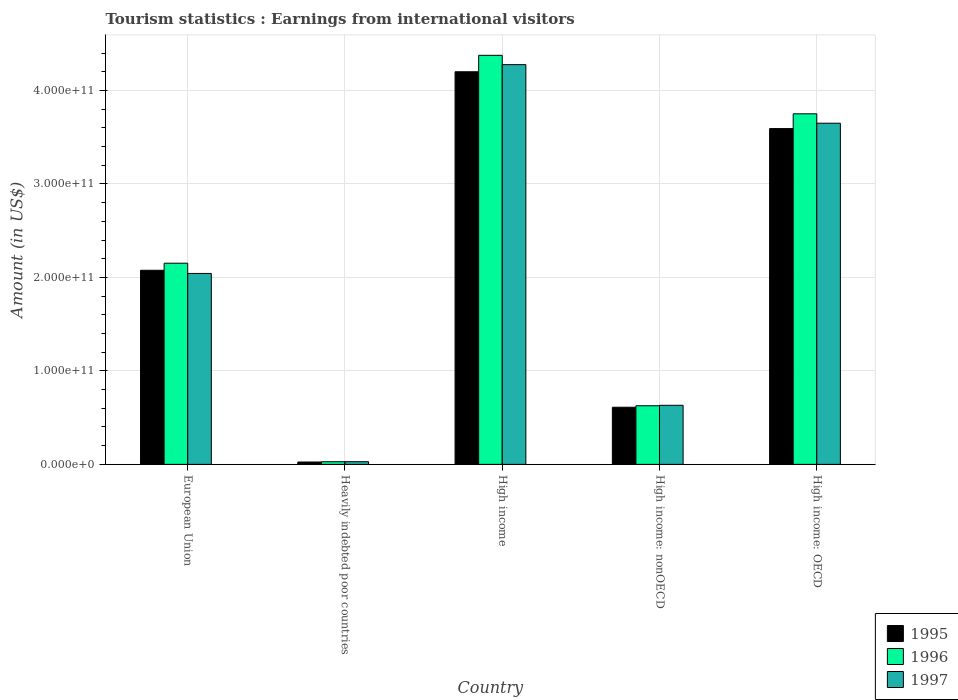How many groups of bars are there?
Your answer should be very brief. 5. How many bars are there on the 4th tick from the right?
Your answer should be compact. 3. In how many cases, is the number of bars for a given country not equal to the number of legend labels?
Ensure brevity in your answer.  0. What is the earnings from international visitors in 1997 in Heavily indebted poor countries?
Give a very brief answer. 2.86e+09. Across all countries, what is the maximum earnings from international visitors in 1997?
Keep it short and to the point. 4.28e+11. Across all countries, what is the minimum earnings from international visitors in 1995?
Offer a very short reply. 2.53e+09. In which country was the earnings from international visitors in 1995 maximum?
Your answer should be very brief. High income. In which country was the earnings from international visitors in 1997 minimum?
Your answer should be very brief. Heavily indebted poor countries. What is the total earnings from international visitors in 1995 in the graph?
Provide a short and direct response. 1.05e+12. What is the difference between the earnings from international visitors in 1997 in European Union and that in High income?
Your response must be concise. -2.23e+11. What is the difference between the earnings from international visitors in 1997 in European Union and the earnings from international visitors in 1995 in High income: nonOECD?
Your response must be concise. 1.43e+11. What is the average earnings from international visitors in 1995 per country?
Offer a terse response. 2.10e+11. What is the difference between the earnings from international visitors of/in 1996 and earnings from international visitors of/in 1995 in High income: OECD?
Your answer should be compact. 1.58e+1. In how many countries, is the earnings from international visitors in 1996 greater than 40000000000 US$?
Keep it short and to the point. 4. What is the ratio of the earnings from international visitors in 1996 in European Union to that in High income?
Keep it short and to the point. 0.49. Is the earnings from international visitors in 1996 in European Union less than that in High income?
Provide a succinct answer. Yes. Is the difference between the earnings from international visitors in 1996 in Heavily indebted poor countries and High income: OECD greater than the difference between the earnings from international visitors in 1995 in Heavily indebted poor countries and High income: OECD?
Your answer should be compact. No. What is the difference between the highest and the second highest earnings from international visitors in 1995?
Ensure brevity in your answer.  6.08e+1. What is the difference between the highest and the lowest earnings from international visitors in 1996?
Your answer should be compact. 4.35e+11. In how many countries, is the earnings from international visitors in 1996 greater than the average earnings from international visitors in 1996 taken over all countries?
Offer a terse response. 2. What does the 2nd bar from the right in High income represents?
Offer a very short reply. 1996. Is it the case that in every country, the sum of the earnings from international visitors in 1996 and earnings from international visitors in 1997 is greater than the earnings from international visitors in 1995?
Your answer should be very brief. Yes. How many bars are there?
Ensure brevity in your answer.  15. Are all the bars in the graph horizontal?
Make the answer very short. No. What is the difference between two consecutive major ticks on the Y-axis?
Provide a succinct answer. 1.00e+11. Are the values on the major ticks of Y-axis written in scientific E-notation?
Offer a very short reply. Yes. Does the graph contain grids?
Provide a succinct answer. Yes. Where does the legend appear in the graph?
Ensure brevity in your answer.  Bottom right. How many legend labels are there?
Ensure brevity in your answer.  3. How are the legend labels stacked?
Give a very brief answer. Vertical. What is the title of the graph?
Offer a terse response. Tourism statistics : Earnings from international visitors. Does "1969" appear as one of the legend labels in the graph?
Ensure brevity in your answer.  No. What is the label or title of the X-axis?
Keep it short and to the point. Country. What is the label or title of the Y-axis?
Make the answer very short. Amount (in US$). What is the Amount (in US$) of 1995 in European Union?
Make the answer very short. 2.08e+11. What is the Amount (in US$) in 1996 in European Union?
Ensure brevity in your answer.  2.15e+11. What is the Amount (in US$) of 1997 in European Union?
Offer a very short reply. 2.04e+11. What is the Amount (in US$) in 1995 in Heavily indebted poor countries?
Ensure brevity in your answer.  2.53e+09. What is the Amount (in US$) of 1996 in Heavily indebted poor countries?
Your answer should be very brief. 2.83e+09. What is the Amount (in US$) in 1997 in Heavily indebted poor countries?
Offer a very short reply. 2.86e+09. What is the Amount (in US$) in 1995 in High income?
Your answer should be compact. 4.20e+11. What is the Amount (in US$) of 1996 in High income?
Ensure brevity in your answer.  4.38e+11. What is the Amount (in US$) in 1997 in High income?
Your response must be concise. 4.28e+11. What is the Amount (in US$) in 1995 in High income: nonOECD?
Make the answer very short. 6.11e+1. What is the Amount (in US$) in 1996 in High income: nonOECD?
Ensure brevity in your answer.  6.27e+1. What is the Amount (in US$) in 1997 in High income: nonOECD?
Your response must be concise. 6.32e+1. What is the Amount (in US$) of 1995 in High income: OECD?
Provide a succinct answer. 3.59e+11. What is the Amount (in US$) in 1996 in High income: OECD?
Make the answer very short. 3.75e+11. What is the Amount (in US$) in 1997 in High income: OECD?
Offer a very short reply. 3.65e+11. Across all countries, what is the maximum Amount (in US$) in 1995?
Your response must be concise. 4.20e+11. Across all countries, what is the maximum Amount (in US$) of 1996?
Give a very brief answer. 4.38e+11. Across all countries, what is the maximum Amount (in US$) of 1997?
Your response must be concise. 4.28e+11. Across all countries, what is the minimum Amount (in US$) of 1995?
Ensure brevity in your answer.  2.53e+09. Across all countries, what is the minimum Amount (in US$) of 1996?
Offer a very short reply. 2.83e+09. Across all countries, what is the minimum Amount (in US$) in 1997?
Your answer should be compact. 2.86e+09. What is the total Amount (in US$) in 1995 in the graph?
Ensure brevity in your answer.  1.05e+12. What is the total Amount (in US$) in 1996 in the graph?
Your answer should be compact. 1.09e+12. What is the total Amount (in US$) in 1997 in the graph?
Keep it short and to the point. 1.06e+12. What is the difference between the Amount (in US$) in 1995 in European Union and that in Heavily indebted poor countries?
Make the answer very short. 2.05e+11. What is the difference between the Amount (in US$) in 1996 in European Union and that in Heavily indebted poor countries?
Your response must be concise. 2.12e+11. What is the difference between the Amount (in US$) of 1997 in European Union and that in Heavily indebted poor countries?
Your answer should be compact. 2.01e+11. What is the difference between the Amount (in US$) of 1995 in European Union and that in High income?
Provide a short and direct response. -2.12e+11. What is the difference between the Amount (in US$) in 1996 in European Union and that in High income?
Offer a very short reply. -2.22e+11. What is the difference between the Amount (in US$) of 1997 in European Union and that in High income?
Keep it short and to the point. -2.23e+11. What is the difference between the Amount (in US$) in 1995 in European Union and that in High income: nonOECD?
Your answer should be very brief. 1.47e+11. What is the difference between the Amount (in US$) in 1996 in European Union and that in High income: nonOECD?
Offer a very short reply. 1.52e+11. What is the difference between the Amount (in US$) of 1997 in European Union and that in High income: nonOECD?
Your response must be concise. 1.41e+11. What is the difference between the Amount (in US$) in 1995 in European Union and that in High income: OECD?
Your answer should be very brief. -1.52e+11. What is the difference between the Amount (in US$) of 1996 in European Union and that in High income: OECD?
Make the answer very short. -1.60e+11. What is the difference between the Amount (in US$) of 1997 in European Union and that in High income: OECD?
Provide a short and direct response. -1.61e+11. What is the difference between the Amount (in US$) in 1995 in Heavily indebted poor countries and that in High income?
Keep it short and to the point. -4.17e+11. What is the difference between the Amount (in US$) of 1996 in Heavily indebted poor countries and that in High income?
Keep it short and to the point. -4.35e+11. What is the difference between the Amount (in US$) in 1997 in Heavily indebted poor countries and that in High income?
Your answer should be very brief. -4.25e+11. What is the difference between the Amount (in US$) of 1995 in Heavily indebted poor countries and that in High income: nonOECD?
Ensure brevity in your answer.  -5.86e+1. What is the difference between the Amount (in US$) of 1996 in Heavily indebted poor countries and that in High income: nonOECD?
Your response must be concise. -5.99e+1. What is the difference between the Amount (in US$) in 1997 in Heavily indebted poor countries and that in High income: nonOECD?
Your answer should be compact. -6.03e+1. What is the difference between the Amount (in US$) of 1995 in Heavily indebted poor countries and that in High income: OECD?
Your response must be concise. -3.57e+11. What is the difference between the Amount (in US$) of 1996 in Heavily indebted poor countries and that in High income: OECD?
Ensure brevity in your answer.  -3.72e+11. What is the difference between the Amount (in US$) of 1997 in Heavily indebted poor countries and that in High income: OECD?
Your response must be concise. -3.62e+11. What is the difference between the Amount (in US$) in 1995 in High income and that in High income: nonOECD?
Ensure brevity in your answer.  3.59e+11. What is the difference between the Amount (in US$) of 1996 in High income and that in High income: nonOECD?
Your answer should be very brief. 3.75e+11. What is the difference between the Amount (in US$) of 1997 in High income and that in High income: nonOECD?
Your answer should be very brief. 3.64e+11. What is the difference between the Amount (in US$) in 1995 in High income and that in High income: OECD?
Provide a short and direct response. 6.08e+1. What is the difference between the Amount (in US$) in 1996 in High income and that in High income: OECD?
Offer a very short reply. 6.26e+1. What is the difference between the Amount (in US$) of 1997 in High income and that in High income: OECD?
Your response must be concise. 6.27e+1. What is the difference between the Amount (in US$) in 1995 in High income: nonOECD and that in High income: OECD?
Make the answer very short. -2.98e+11. What is the difference between the Amount (in US$) of 1996 in High income: nonOECD and that in High income: OECD?
Keep it short and to the point. -3.12e+11. What is the difference between the Amount (in US$) in 1997 in High income: nonOECD and that in High income: OECD?
Your response must be concise. -3.02e+11. What is the difference between the Amount (in US$) in 1995 in European Union and the Amount (in US$) in 1996 in Heavily indebted poor countries?
Your answer should be compact. 2.05e+11. What is the difference between the Amount (in US$) of 1995 in European Union and the Amount (in US$) of 1997 in Heavily indebted poor countries?
Keep it short and to the point. 2.05e+11. What is the difference between the Amount (in US$) of 1996 in European Union and the Amount (in US$) of 1997 in Heavily indebted poor countries?
Make the answer very short. 2.12e+11. What is the difference between the Amount (in US$) of 1995 in European Union and the Amount (in US$) of 1996 in High income?
Ensure brevity in your answer.  -2.30e+11. What is the difference between the Amount (in US$) in 1995 in European Union and the Amount (in US$) in 1997 in High income?
Provide a short and direct response. -2.20e+11. What is the difference between the Amount (in US$) in 1996 in European Union and the Amount (in US$) in 1997 in High income?
Offer a very short reply. -2.12e+11. What is the difference between the Amount (in US$) in 1995 in European Union and the Amount (in US$) in 1996 in High income: nonOECD?
Provide a short and direct response. 1.45e+11. What is the difference between the Amount (in US$) in 1995 in European Union and the Amount (in US$) in 1997 in High income: nonOECD?
Your response must be concise. 1.44e+11. What is the difference between the Amount (in US$) of 1996 in European Union and the Amount (in US$) of 1997 in High income: nonOECD?
Ensure brevity in your answer.  1.52e+11. What is the difference between the Amount (in US$) in 1995 in European Union and the Amount (in US$) in 1996 in High income: OECD?
Make the answer very short. -1.67e+11. What is the difference between the Amount (in US$) of 1995 in European Union and the Amount (in US$) of 1997 in High income: OECD?
Keep it short and to the point. -1.57e+11. What is the difference between the Amount (in US$) of 1996 in European Union and the Amount (in US$) of 1997 in High income: OECD?
Your answer should be compact. -1.50e+11. What is the difference between the Amount (in US$) of 1995 in Heavily indebted poor countries and the Amount (in US$) of 1996 in High income?
Keep it short and to the point. -4.35e+11. What is the difference between the Amount (in US$) of 1995 in Heavily indebted poor countries and the Amount (in US$) of 1997 in High income?
Provide a short and direct response. -4.25e+11. What is the difference between the Amount (in US$) of 1996 in Heavily indebted poor countries and the Amount (in US$) of 1997 in High income?
Ensure brevity in your answer.  -4.25e+11. What is the difference between the Amount (in US$) in 1995 in Heavily indebted poor countries and the Amount (in US$) in 1996 in High income: nonOECD?
Your answer should be very brief. -6.02e+1. What is the difference between the Amount (in US$) of 1995 in Heavily indebted poor countries and the Amount (in US$) of 1997 in High income: nonOECD?
Ensure brevity in your answer.  -6.07e+1. What is the difference between the Amount (in US$) of 1996 in Heavily indebted poor countries and the Amount (in US$) of 1997 in High income: nonOECD?
Provide a succinct answer. -6.04e+1. What is the difference between the Amount (in US$) in 1995 in Heavily indebted poor countries and the Amount (in US$) in 1996 in High income: OECD?
Your answer should be compact. -3.72e+11. What is the difference between the Amount (in US$) in 1995 in Heavily indebted poor countries and the Amount (in US$) in 1997 in High income: OECD?
Your answer should be very brief. -3.62e+11. What is the difference between the Amount (in US$) in 1996 in Heavily indebted poor countries and the Amount (in US$) in 1997 in High income: OECD?
Your answer should be very brief. -3.62e+11. What is the difference between the Amount (in US$) in 1995 in High income and the Amount (in US$) in 1996 in High income: nonOECD?
Your answer should be very brief. 3.57e+11. What is the difference between the Amount (in US$) in 1995 in High income and the Amount (in US$) in 1997 in High income: nonOECD?
Provide a succinct answer. 3.57e+11. What is the difference between the Amount (in US$) in 1996 in High income and the Amount (in US$) in 1997 in High income: nonOECD?
Your answer should be very brief. 3.74e+11. What is the difference between the Amount (in US$) of 1995 in High income and the Amount (in US$) of 1996 in High income: OECD?
Your answer should be compact. 4.50e+1. What is the difference between the Amount (in US$) of 1995 in High income and the Amount (in US$) of 1997 in High income: OECD?
Offer a terse response. 5.50e+1. What is the difference between the Amount (in US$) of 1996 in High income and the Amount (in US$) of 1997 in High income: OECD?
Offer a very short reply. 7.26e+1. What is the difference between the Amount (in US$) in 1995 in High income: nonOECD and the Amount (in US$) in 1996 in High income: OECD?
Your answer should be very brief. -3.14e+11. What is the difference between the Amount (in US$) in 1995 in High income: nonOECD and the Amount (in US$) in 1997 in High income: OECD?
Make the answer very short. -3.04e+11. What is the difference between the Amount (in US$) in 1996 in High income: nonOECD and the Amount (in US$) in 1997 in High income: OECD?
Provide a short and direct response. -3.02e+11. What is the average Amount (in US$) of 1995 per country?
Offer a terse response. 2.10e+11. What is the average Amount (in US$) in 1996 per country?
Offer a very short reply. 2.19e+11. What is the average Amount (in US$) in 1997 per country?
Offer a terse response. 2.13e+11. What is the difference between the Amount (in US$) in 1995 and Amount (in US$) in 1996 in European Union?
Your answer should be compact. -7.57e+09. What is the difference between the Amount (in US$) of 1995 and Amount (in US$) of 1997 in European Union?
Offer a very short reply. 3.39e+09. What is the difference between the Amount (in US$) in 1996 and Amount (in US$) in 1997 in European Union?
Provide a succinct answer. 1.10e+1. What is the difference between the Amount (in US$) of 1995 and Amount (in US$) of 1996 in Heavily indebted poor countries?
Make the answer very short. -3.01e+08. What is the difference between the Amount (in US$) in 1995 and Amount (in US$) in 1997 in Heavily indebted poor countries?
Provide a short and direct response. -3.25e+08. What is the difference between the Amount (in US$) of 1996 and Amount (in US$) of 1997 in Heavily indebted poor countries?
Ensure brevity in your answer.  -2.43e+07. What is the difference between the Amount (in US$) of 1995 and Amount (in US$) of 1996 in High income?
Your answer should be very brief. -1.76e+1. What is the difference between the Amount (in US$) in 1995 and Amount (in US$) in 1997 in High income?
Make the answer very short. -7.62e+09. What is the difference between the Amount (in US$) of 1996 and Amount (in US$) of 1997 in High income?
Make the answer very short. 9.95e+09. What is the difference between the Amount (in US$) in 1995 and Amount (in US$) in 1996 in High income: nonOECD?
Offer a very short reply. -1.58e+09. What is the difference between the Amount (in US$) in 1995 and Amount (in US$) in 1997 in High income: nonOECD?
Ensure brevity in your answer.  -2.08e+09. What is the difference between the Amount (in US$) in 1996 and Amount (in US$) in 1997 in High income: nonOECD?
Provide a succinct answer. -4.95e+08. What is the difference between the Amount (in US$) in 1995 and Amount (in US$) in 1996 in High income: OECD?
Your answer should be very brief. -1.58e+1. What is the difference between the Amount (in US$) of 1995 and Amount (in US$) of 1997 in High income: OECD?
Offer a very short reply. -5.74e+09. What is the difference between the Amount (in US$) of 1996 and Amount (in US$) of 1997 in High income: OECD?
Make the answer very short. 1.01e+1. What is the ratio of the Amount (in US$) in 1995 in European Union to that in Heavily indebted poor countries?
Offer a very short reply. 81.97. What is the ratio of the Amount (in US$) in 1996 in European Union to that in Heavily indebted poor countries?
Your answer should be compact. 75.94. What is the ratio of the Amount (in US$) in 1997 in European Union to that in Heavily indebted poor countries?
Keep it short and to the point. 71.46. What is the ratio of the Amount (in US$) of 1995 in European Union to that in High income?
Your response must be concise. 0.49. What is the ratio of the Amount (in US$) in 1996 in European Union to that in High income?
Make the answer very short. 0.49. What is the ratio of the Amount (in US$) of 1997 in European Union to that in High income?
Your response must be concise. 0.48. What is the ratio of the Amount (in US$) of 1995 in European Union to that in High income: nonOECD?
Your response must be concise. 3.4. What is the ratio of the Amount (in US$) of 1996 in European Union to that in High income: nonOECD?
Make the answer very short. 3.43. What is the ratio of the Amount (in US$) in 1997 in European Union to that in High income: nonOECD?
Give a very brief answer. 3.23. What is the ratio of the Amount (in US$) of 1995 in European Union to that in High income: OECD?
Offer a terse response. 0.58. What is the ratio of the Amount (in US$) of 1996 in European Union to that in High income: OECD?
Your answer should be very brief. 0.57. What is the ratio of the Amount (in US$) in 1997 in European Union to that in High income: OECD?
Offer a very short reply. 0.56. What is the ratio of the Amount (in US$) of 1995 in Heavily indebted poor countries to that in High income?
Offer a very short reply. 0.01. What is the ratio of the Amount (in US$) of 1996 in Heavily indebted poor countries to that in High income?
Your answer should be compact. 0.01. What is the ratio of the Amount (in US$) of 1997 in Heavily indebted poor countries to that in High income?
Give a very brief answer. 0.01. What is the ratio of the Amount (in US$) of 1995 in Heavily indebted poor countries to that in High income: nonOECD?
Your answer should be compact. 0.04. What is the ratio of the Amount (in US$) in 1996 in Heavily indebted poor countries to that in High income: nonOECD?
Ensure brevity in your answer.  0.05. What is the ratio of the Amount (in US$) of 1997 in Heavily indebted poor countries to that in High income: nonOECD?
Give a very brief answer. 0.05. What is the ratio of the Amount (in US$) in 1995 in Heavily indebted poor countries to that in High income: OECD?
Your answer should be compact. 0.01. What is the ratio of the Amount (in US$) in 1996 in Heavily indebted poor countries to that in High income: OECD?
Your answer should be very brief. 0.01. What is the ratio of the Amount (in US$) in 1997 in Heavily indebted poor countries to that in High income: OECD?
Provide a short and direct response. 0.01. What is the ratio of the Amount (in US$) in 1995 in High income to that in High income: nonOECD?
Keep it short and to the point. 6.87. What is the ratio of the Amount (in US$) in 1996 in High income to that in High income: nonOECD?
Your answer should be compact. 6.98. What is the ratio of the Amount (in US$) of 1997 in High income to that in High income: nonOECD?
Offer a very short reply. 6.77. What is the ratio of the Amount (in US$) of 1995 in High income to that in High income: OECD?
Offer a terse response. 1.17. What is the ratio of the Amount (in US$) in 1996 in High income to that in High income: OECD?
Your answer should be very brief. 1.17. What is the ratio of the Amount (in US$) of 1997 in High income to that in High income: OECD?
Offer a terse response. 1.17. What is the ratio of the Amount (in US$) in 1995 in High income: nonOECD to that in High income: OECD?
Your answer should be very brief. 0.17. What is the ratio of the Amount (in US$) of 1996 in High income: nonOECD to that in High income: OECD?
Your answer should be very brief. 0.17. What is the ratio of the Amount (in US$) in 1997 in High income: nonOECD to that in High income: OECD?
Ensure brevity in your answer.  0.17. What is the difference between the highest and the second highest Amount (in US$) in 1995?
Offer a terse response. 6.08e+1. What is the difference between the highest and the second highest Amount (in US$) in 1996?
Your answer should be compact. 6.26e+1. What is the difference between the highest and the second highest Amount (in US$) of 1997?
Give a very brief answer. 6.27e+1. What is the difference between the highest and the lowest Amount (in US$) of 1995?
Offer a very short reply. 4.17e+11. What is the difference between the highest and the lowest Amount (in US$) of 1996?
Provide a short and direct response. 4.35e+11. What is the difference between the highest and the lowest Amount (in US$) of 1997?
Provide a short and direct response. 4.25e+11. 